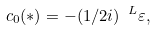Convert formula to latex. <formula><loc_0><loc_0><loc_500><loc_500>c _ { 0 } ( \ast ) = - ( 1 / 2 i ) \ ^ { L } \varepsilon ,</formula> 